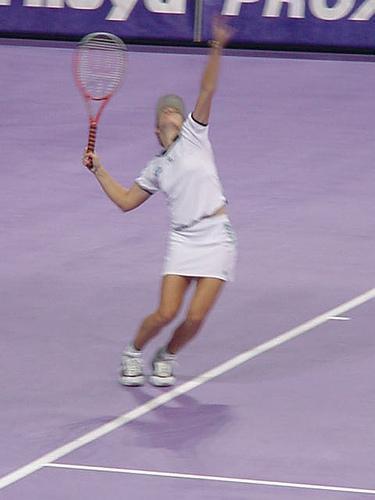How many numbers are on the clock tower?
Give a very brief answer. 0. 